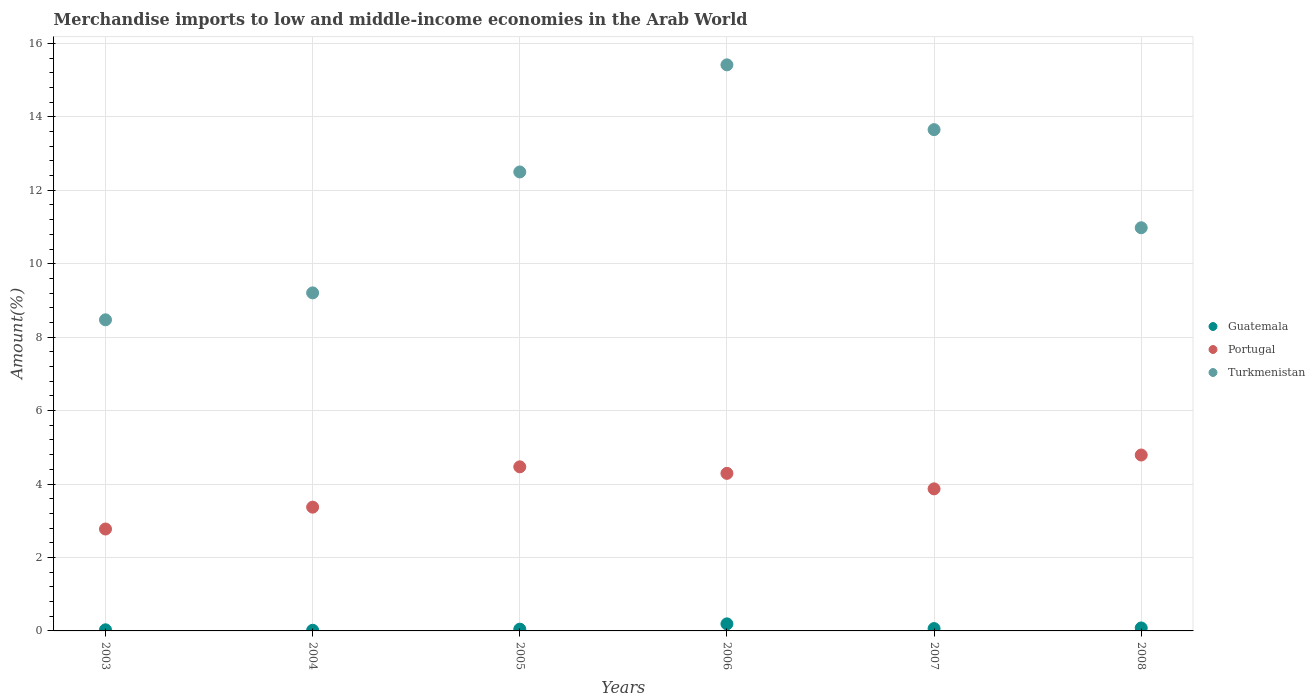Is the number of dotlines equal to the number of legend labels?
Offer a very short reply. Yes. What is the percentage of amount earned from merchandise imports in Portugal in 2007?
Ensure brevity in your answer.  3.87. Across all years, what is the maximum percentage of amount earned from merchandise imports in Guatemala?
Offer a terse response. 0.19. Across all years, what is the minimum percentage of amount earned from merchandise imports in Portugal?
Ensure brevity in your answer.  2.78. In which year was the percentage of amount earned from merchandise imports in Guatemala maximum?
Keep it short and to the point. 2006. What is the total percentage of amount earned from merchandise imports in Portugal in the graph?
Your answer should be very brief. 23.56. What is the difference between the percentage of amount earned from merchandise imports in Guatemala in 2005 and that in 2007?
Provide a succinct answer. -0.02. What is the difference between the percentage of amount earned from merchandise imports in Guatemala in 2003 and the percentage of amount earned from merchandise imports in Turkmenistan in 2005?
Offer a terse response. -12.47. What is the average percentage of amount earned from merchandise imports in Guatemala per year?
Make the answer very short. 0.07. In the year 2007, what is the difference between the percentage of amount earned from merchandise imports in Turkmenistan and percentage of amount earned from merchandise imports in Portugal?
Your answer should be very brief. 9.78. What is the ratio of the percentage of amount earned from merchandise imports in Turkmenistan in 2007 to that in 2008?
Offer a terse response. 1.24. Is the difference between the percentage of amount earned from merchandise imports in Turkmenistan in 2004 and 2007 greater than the difference between the percentage of amount earned from merchandise imports in Portugal in 2004 and 2007?
Your response must be concise. No. What is the difference between the highest and the second highest percentage of amount earned from merchandise imports in Portugal?
Ensure brevity in your answer.  0.32. What is the difference between the highest and the lowest percentage of amount earned from merchandise imports in Guatemala?
Ensure brevity in your answer.  0.17. Is the sum of the percentage of amount earned from merchandise imports in Guatemala in 2003 and 2007 greater than the maximum percentage of amount earned from merchandise imports in Turkmenistan across all years?
Provide a short and direct response. No. Is it the case that in every year, the sum of the percentage of amount earned from merchandise imports in Guatemala and percentage of amount earned from merchandise imports in Turkmenistan  is greater than the percentage of amount earned from merchandise imports in Portugal?
Provide a short and direct response. Yes. How many dotlines are there?
Offer a very short reply. 3. How many years are there in the graph?
Provide a succinct answer. 6. Where does the legend appear in the graph?
Ensure brevity in your answer.  Center right. How are the legend labels stacked?
Provide a short and direct response. Vertical. What is the title of the graph?
Offer a terse response. Merchandise imports to low and middle-income economies in the Arab World. What is the label or title of the X-axis?
Provide a short and direct response. Years. What is the label or title of the Y-axis?
Offer a very short reply. Amount(%). What is the Amount(%) of Guatemala in 2003?
Make the answer very short. 0.03. What is the Amount(%) in Portugal in 2003?
Offer a terse response. 2.78. What is the Amount(%) in Turkmenistan in 2003?
Give a very brief answer. 8.47. What is the Amount(%) of Guatemala in 2004?
Make the answer very short. 0.02. What is the Amount(%) in Portugal in 2004?
Offer a terse response. 3.37. What is the Amount(%) of Turkmenistan in 2004?
Provide a short and direct response. 9.21. What is the Amount(%) in Guatemala in 2005?
Give a very brief answer. 0.05. What is the Amount(%) in Portugal in 2005?
Offer a terse response. 4.47. What is the Amount(%) of Turkmenistan in 2005?
Keep it short and to the point. 12.5. What is the Amount(%) of Guatemala in 2006?
Your answer should be compact. 0.19. What is the Amount(%) of Portugal in 2006?
Provide a succinct answer. 4.29. What is the Amount(%) in Turkmenistan in 2006?
Your answer should be compact. 15.42. What is the Amount(%) of Guatemala in 2007?
Ensure brevity in your answer.  0.06. What is the Amount(%) of Portugal in 2007?
Your response must be concise. 3.87. What is the Amount(%) in Turkmenistan in 2007?
Keep it short and to the point. 13.65. What is the Amount(%) in Guatemala in 2008?
Offer a terse response. 0.08. What is the Amount(%) of Portugal in 2008?
Ensure brevity in your answer.  4.79. What is the Amount(%) in Turkmenistan in 2008?
Offer a very short reply. 10.98. Across all years, what is the maximum Amount(%) in Guatemala?
Your answer should be compact. 0.19. Across all years, what is the maximum Amount(%) of Portugal?
Offer a very short reply. 4.79. Across all years, what is the maximum Amount(%) in Turkmenistan?
Offer a very short reply. 15.42. Across all years, what is the minimum Amount(%) of Guatemala?
Offer a terse response. 0.02. Across all years, what is the minimum Amount(%) of Portugal?
Offer a terse response. 2.78. Across all years, what is the minimum Amount(%) in Turkmenistan?
Offer a very short reply. 8.47. What is the total Amount(%) in Guatemala in the graph?
Ensure brevity in your answer.  0.43. What is the total Amount(%) of Portugal in the graph?
Provide a succinct answer. 23.56. What is the total Amount(%) of Turkmenistan in the graph?
Offer a very short reply. 70.22. What is the difference between the Amount(%) in Guatemala in 2003 and that in 2004?
Make the answer very short. 0.01. What is the difference between the Amount(%) in Portugal in 2003 and that in 2004?
Keep it short and to the point. -0.6. What is the difference between the Amount(%) of Turkmenistan in 2003 and that in 2004?
Offer a terse response. -0.73. What is the difference between the Amount(%) of Guatemala in 2003 and that in 2005?
Offer a terse response. -0.02. What is the difference between the Amount(%) in Portugal in 2003 and that in 2005?
Offer a terse response. -1.69. What is the difference between the Amount(%) in Turkmenistan in 2003 and that in 2005?
Offer a terse response. -4.03. What is the difference between the Amount(%) of Guatemala in 2003 and that in 2006?
Offer a terse response. -0.16. What is the difference between the Amount(%) in Portugal in 2003 and that in 2006?
Provide a succinct answer. -1.52. What is the difference between the Amount(%) of Turkmenistan in 2003 and that in 2006?
Your answer should be very brief. -6.94. What is the difference between the Amount(%) in Guatemala in 2003 and that in 2007?
Keep it short and to the point. -0.03. What is the difference between the Amount(%) of Portugal in 2003 and that in 2007?
Make the answer very short. -1.09. What is the difference between the Amount(%) of Turkmenistan in 2003 and that in 2007?
Ensure brevity in your answer.  -5.18. What is the difference between the Amount(%) in Guatemala in 2003 and that in 2008?
Ensure brevity in your answer.  -0.05. What is the difference between the Amount(%) in Portugal in 2003 and that in 2008?
Offer a terse response. -2.02. What is the difference between the Amount(%) of Turkmenistan in 2003 and that in 2008?
Offer a very short reply. -2.51. What is the difference between the Amount(%) in Guatemala in 2004 and that in 2005?
Offer a terse response. -0.03. What is the difference between the Amount(%) of Portugal in 2004 and that in 2005?
Your response must be concise. -1.1. What is the difference between the Amount(%) of Turkmenistan in 2004 and that in 2005?
Make the answer very short. -3.29. What is the difference between the Amount(%) of Guatemala in 2004 and that in 2006?
Offer a terse response. -0.17. What is the difference between the Amount(%) in Portugal in 2004 and that in 2006?
Your answer should be compact. -0.92. What is the difference between the Amount(%) of Turkmenistan in 2004 and that in 2006?
Your answer should be compact. -6.21. What is the difference between the Amount(%) in Guatemala in 2004 and that in 2007?
Keep it short and to the point. -0.05. What is the difference between the Amount(%) of Portugal in 2004 and that in 2007?
Give a very brief answer. -0.5. What is the difference between the Amount(%) of Turkmenistan in 2004 and that in 2007?
Offer a terse response. -4.45. What is the difference between the Amount(%) in Guatemala in 2004 and that in 2008?
Your answer should be compact. -0.06. What is the difference between the Amount(%) of Portugal in 2004 and that in 2008?
Your answer should be compact. -1.42. What is the difference between the Amount(%) in Turkmenistan in 2004 and that in 2008?
Keep it short and to the point. -1.77. What is the difference between the Amount(%) in Guatemala in 2005 and that in 2006?
Offer a terse response. -0.14. What is the difference between the Amount(%) in Portugal in 2005 and that in 2006?
Keep it short and to the point. 0.18. What is the difference between the Amount(%) of Turkmenistan in 2005 and that in 2006?
Provide a succinct answer. -2.92. What is the difference between the Amount(%) of Guatemala in 2005 and that in 2007?
Ensure brevity in your answer.  -0.02. What is the difference between the Amount(%) in Portugal in 2005 and that in 2007?
Your response must be concise. 0.6. What is the difference between the Amount(%) of Turkmenistan in 2005 and that in 2007?
Offer a very short reply. -1.15. What is the difference between the Amount(%) in Guatemala in 2005 and that in 2008?
Provide a short and direct response. -0.03. What is the difference between the Amount(%) of Portugal in 2005 and that in 2008?
Make the answer very short. -0.32. What is the difference between the Amount(%) of Turkmenistan in 2005 and that in 2008?
Offer a very short reply. 1.52. What is the difference between the Amount(%) in Guatemala in 2006 and that in 2007?
Your response must be concise. 0.13. What is the difference between the Amount(%) in Portugal in 2006 and that in 2007?
Keep it short and to the point. 0.42. What is the difference between the Amount(%) of Turkmenistan in 2006 and that in 2007?
Your answer should be compact. 1.76. What is the difference between the Amount(%) in Guatemala in 2006 and that in 2008?
Keep it short and to the point. 0.11. What is the difference between the Amount(%) in Portugal in 2006 and that in 2008?
Provide a short and direct response. -0.5. What is the difference between the Amount(%) of Turkmenistan in 2006 and that in 2008?
Your response must be concise. 4.44. What is the difference between the Amount(%) of Guatemala in 2007 and that in 2008?
Provide a short and direct response. -0.02. What is the difference between the Amount(%) of Portugal in 2007 and that in 2008?
Make the answer very short. -0.92. What is the difference between the Amount(%) in Turkmenistan in 2007 and that in 2008?
Provide a short and direct response. 2.67. What is the difference between the Amount(%) of Guatemala in 2003 and the Amount(%) of Portugal in 2004?
Your answer should be very brief. -3.34. What is the difference between the Amount(%) of Guatemala in 2003 and the Amount(%) of Turkmenistan in 2004?
Make the answer very short. -9.18. What is the difference between the Amount(%) of Portugal in 2003 and the Amount(%) of Turkmenistan in 2004?
Your response must be concise. -6.43. What is the difference between the Amount(%) in Guatemala in 2003 and the Amount(%) in Portugal in 2005?
Your answer should be very brief. -4.44. What is the difference between the Amount(%) of Guatemala in 2003 and the Amount(%) of Turkmenistan in 2005?
Your response must be concise. -12.47. What is the difference between the Amount(%) of Portugal in 2003 and the Amount(%) of Turkmenistan in 2005?
Your answer should be compact. -9.72. What is the difference between the Amount(%) of Guatemala in 2003 and the Amount(%) of Portugal in 2006?
Keep it short and to the point. -4.26. What is the difference between the Amount(%) in Guatemala in 2003 and the Amount(%) in Turkmenistan in 2006?
Keep it short and to the point. -15.38. What is the difference between the Amount(%) of Portugal in 2003 and the Amount(%) of Turkmenistan in 2006?
Offer a terse response. -12.64. What is the difference between the Amount(%) of Guatemala in 2003 and the Amount(%) of Portugal in 2007?
Make the answer very short. -3.84. What is the difference between the Amount(%) of Guatemala in 2003 and the Amount(%) of Turkmenistan in 2007?
Give a very brief answer. -13.62. What is the difference between the Amount(%) in Portugal in 2003 and the Amount(%) in Turkmenistan in 2007?
Give a very brief answer. -10.88. What is the difference between the Amount(%) in Guatemala in 2003 and the Amount(%) in Portugal in 2008?
Provide a succinct answer. -4.76. What is the difference between the Amount(%) of Guatemala in 2003 and the Amount(%) of Turkmenistan in 2008?
Offer a very short reply. -10.95. What is the difference between the Amount(%) of Portugal in 2003 and the Amount(%) of Turkmenistan in 2008?
Your response must be concise. -8.2. What is the difference between the Amount(%) of Guatemala in 2004 and the Amount(%) of Portugal in 2005?
Ensure brevity in your answer.  -4.45. What is the difference between the Amount(%) of Guatemala in 2004 and the Amount(%) of Turkmenistan in 2005?
Offer a very short reply. -12.48. What is the difference between the Amount(%) in Portugal in 2004 and the Amount(%) in Turkmenistan in 2005?
Ensure brevity in your answer.  -9.13. What is the difference between the Amount(%) in Guatemala in 2004 and the Amount(%) in Portugal in 2006?
Your answer should be compact. -4.27. What is the difference between the Amount(%) of Guatemala in 2004 and the Amount(%) of Turkmenistan in 2006?
Your answer should be very brief. -15.4. What is the difference between the Amount(%) of Portugal in 2004 and the Amount(%) of Turkmenistan in 2006?
Give a very brief answer. -12.04. What is the difference between the Amount(%) of Guatemala in 2004 and the Amount(%) of Portugal in 2007?
Ensure brevity in your answer.  -3.85. What is the difference between the Amount(%) in Guatemala in 2004 and the Amount(%) in Turkmenistan in 2007?
Provide a short and direct response. -13.63. What is the difference between the Amount(%) of Portugal in 2004 and the Amount(%) of Turkmenistan in 2007?
Give a very brief answer. -10.28. What is the difference between the Amount(%) in Guatemala in 2004 and the Amount(%) in Portugal in 2008?
Your answer should be compact. -4.77. What is the difference between the Amount(%) of Guatemala in 2004 and the Amount(%) of Turkmenistan in 2008?
Provide a succinct answer. -10.96. What is the difference between the Amount(%) of Portugal in 2004 and the Amount(%) of Turkmenistan in 2008?
Keep it short and to the point. -7.61. What is the difference between the Amount(%) of Guatemala in 2005 and the Amount(%) of Portugal in 2006?
Keep it short and to the point. -4.24. What is the difference between the Amount(%) of Guatemala in 2005 and the Amount(%) of Turkmenistan in 2006?
Your answer should be compact. -15.37. What is the difference between the Amount(%) of Portugal in 2005 and the Amount(%) of Turkmenistan in 2006?
Your answer should be very brief. -10.95. What is the difference between the Amount(%) of Guatemala in 2005 and the Amount(%) of Portugal in 2007?
Offer a terse response. -3.82. What is the difference between the Amount(%) in Guatemala in 2005 and the Amount(%) in Turkmenistan in 2007?
Provide a succinct answer. -13.6. What is the difference between the Amount(%) of Portugal in 2005 and the Amount(%) of Turkmenistan in 2007?
Offer a terse response. -9.18. What is the difference between the Amount(%) of Guatemala in 2005 and the Amount(%) of Portugal in 2008?
Your response must be concise. -4.74. What is the difference between the Amount(%) in Guatemala in 2005 and the Amount(%) in Turkmenistan in 2008?
Provide a short and direct response. -10.93. What is the difference between the Amount(%) in Portugal in 2005 and the Amount(%) in Turkmenistan in 2008?
Your answer should be compact. -6.51. What is the difference between the Amount(%) of Guatemala in 2006 and the Amount(%) of Portugal in 2007?
Your answer should be very brief. -3.68. What is the difference between the Amount(%) of Guatemala in 2006 and the Amount(%) of Turkmenistan in 2007?
Ensure brevity in your answer.  -13.46. What is the difference between the Amount(%) in Portugal in 2006 and the Amount(%) in Turkmenistan in 2007?
Provide a succinct answer. -9.36. What is the difference between the Amount(%) of Guatemala in 2006 and the Amount(%) of Portugal in 2008?
Your answer should be compact. -4.6. What is the difference between the Amount(%) of Guatemala in 2006 and the Amount(%) of Turkmenistan in 2008?
Your answer should be compact. -10.79. What is the difference between the Amount(%) of Portugal in 2006 and the Amount(%) of Turkmenistan in 2008?
Offer a very short reply. -6.69. What is the difference between the Amount(%) of Guatemala in 2007 and the Amount(%) of Portugal in 2008?
Ensure brevity in your answer.  -4.73. What is the difference between the Amount(%) in Guatemala in 2007 and the Amount(%) in Turkmenistan in 2008?
Provide a short and direct response. -10.92. What is the difference between the Amount(%) in Portugal in 2007 and the Amount(%) in Turkmenistan in 2008?
Offer a terse response. -7.11. What is the average Amount(%) in Guatemala per year?
Give a very brief answer. 0.07. What is the average Amount(%) in Portugal per year?
Your response must be concise. 3.93. What is the average Amount(%) in Turkmenistan per year?
Ensure brevity in your answer.  11.7. In the year 2003, what is the difference between the Amount(%) of Guatemala and Amount(%) of Portugal?
Your answer should be compact. -2.74. In the year 2003, what is the difference between the Amount(%) in Guatemala and Amount(%) in Turkmenistan?
Make the answer very short. -8.44. In the year 2003, what is the difference between the Amount(%) of Portugal and Amount(%) of Turkmenistan?
Offer a very short reply. -5.7. In the year 2004, what is the difference between the Amount(%) of Guatemala and Amount(%) of Portugal?
Your response must be concise. -3.35. In the year 2004, what is the difference between the Amount(%) of Guatemala and Amount(%) of Turkmenistan?
Your answer should be very brief. -9.19. In the year 2004, what is the difference between the Amount(%) of Portugal and Amount(%) of Turkmenistan?
Ensure brevity in your answer.  -5.84. In the year 2005, what is the difference between the Amount(%) in Guatemala and Amount(%) in Portugal?
Provide a succinct answer. -4.42. In the year 2005, what is the difference between the Amount(%) of Guatemala and Amount(%) of Turkmenistan?
Your answer should be compact. -12.45. In the year 2005, what is the difference between the Amount(%) in Portugal and Amount(%) in Turkmenistan?
Keep it short and to the point. -8.03. In the year 2006, what is the difference between the Amount(%) of Guatemala and Amount(%) of Portugal?
Offer a very short reply. -4.1. In the year 2006, what is the difference between the Amount(%) of Guatemala and Amount(%) of Turkmenistan?
Keep it short and to the point. -15.22. In the year 2006, what is the difference between the Amount(%) of Portugal and Amount(%) of Turkmenistan?
Your answer should be compact. -11.12. In the year 2007, what is the difference between the Amount(%) in Guatemala and Amount(%) in Portugal?
Your answer should be compact. -3.81. In the year 2007, what is the difference between the Amount(%) of Guatemala and Amount(%) of Turkmenistan?
Your response must be concise. -13.59. In the year 2007, what is the difference between the Amount(%) in Portugal and Amount(%) in Turkmenistan?
Keep it short and to the point. -9.78. In the year 2008, what is the difference between the Amount(%) in Guatemala and Amount(%) in Portugal?
Offer a terse response. -4.71. In the year 2008, what is the difference between the Amount(%) of Guatemala and Amount(%) of Turkmenistan?
Provide a short and direct response. -10.9. In the year 2008, what is the difference between the Amount(%) of Portugal and Amount(%) of Turkmenistan?
Ensure brevity in your answer.  -6.19. What is the ratio of the Amount(%) in Guatemala in 2003 to that in 2004?
Make the answer very short. 1.71. What is the ratio of the Amount(%) in Portugal in 2003 to that in 2004?
Keep it short and to the point. 0.82. What is the ratio of the Amount(%) of Turkmenistan in 2003 to that in 2004?
Make the answer very short. 0.92. What is the ratio of the Amount(%) in Guatemala in 2003 to that in 2005?
Your answer should be very brief. 0.64. What is the ratio of the Amount(%) in Portugal in 2003 to that in 2005?
Ensure brevity in your answer.  0.62. What is the ratio of the Amount(%) of Turkmenistan in 2003 to that in 2005?
Your response must be concise. 0.68. What is the ratio of the Amount(%) in Guatemala in 2003 to that in 2006?
Offer a very short reply. 0.16. What is the ratio of the Amount(%) of Portugal in 2003 to that in 2006?
Give a very brief answer. 0.65. What is the ratio of the Amount(%) in Turkmenistan in 2003 to that in 2006?
Offer a very short reply. 0.55. What is the ratio of the Amount(%) in Guatemala in 2003 to that in 2007?
Offer a terse response. 0.48. What is the ratio of the Amount(%) in Portugal in 2003 to that in 2007?
Your answer should be very brief. 0.72. What is the ratio of the Amount(%) of Turkmenistan in 2003 to that in 2007?
Provide a short and direct response. 0.62. What is the ratio of the Amount(%) of Guatemala in 2003 to that in 2008?
Give a very brief answer. 0.38. What is the ratio of the Amount(%) in Portugal in 2003 to that in 2008?
Provide a short and direct response. 0.58. What is the ratio of the Amount(%) of Turkmenistan in 2003 to that in 2008?
Offer a very short reply. 0.77. What is the ratio of the Amount(%) of Guatemala in 2004 to that in 2005?
Make the answer very short. 0.37. What is the ratio of the Amount(%) of Portugal in 2004 to that in 2005?
Offer a terse response. 0.75. What is the ratio of the Amount(%) of Turkmenistan in 2004 to that in 2005?
Your answer should be compact. 0.74. What is the ratio of the Amount(%) of Guatemala in 2004 to that in 2006?
Offer a very short reply. 0.09. What is the ratio of the Amount(%) of Portugal in 2004 to that in 2006?
Offer a very short reply. 0.79. What is the ratio of the Amount(%) in Turkmenistan in 2004 to that in 2006?
Offer a very short reply. 0.6. What is the ratio of the Amount(%) of Guatemala in 2004 to that in 2007?
Keep it short and to the point. 0.28. What is the ratio of the Amount(%) of Portugal in 2004 to that in 2007?
Ensure brevity in your answer.  0.87. What is the ratio of the Amount(%) of Turkmenistan in 2004 to that in 2007?
Provide a succinct answer. 0.67. What is the ratio of the Amount(%) of Guatemala in 2004 to that in 2008?
Keep it short and to the point. 0.22. What is the ratio of the Amount(%) of Portugal in 2004 to that in 2008?
Give a very brief answer. 0.7. What is the ratio of the Amount(%) in Turkmenistan in 2004 to that in 2008?
Offer a terse response. 0.84. What is the ratio of the Amount(%) in Guatemala in 2005 to that in 2006?
Offer a terse response. 0.25. What is the ratio of the Amount(%) in Portugal in 2005 to that in 2006?
Keep it short and to the point. 1.04. What is the ratio of the Amount(%) in Turkmenistan in 2005 to that in 2006?
Ensure brevity in your answer.  0.81. What is the ratio of the Amount(%) in Guatemala in 2005 to that in 2007?
Offer a very short reply. 0.75. What is the ratio of the Amount(%) of Portugal in 2005 to that in 2007?
Your response must be concise. 1.16. What is the ratio of the Amount(%) in Turkmenistan in 2005 to that in 2007?
Your answer should be compact. 0.92. What is the ratio of the Amount(%) of Guatemala in 2005 to that in 2008?
Offer a very short reply. 0.59. What is the ratio of the Amount(%) in Portugal in 2005 to that in 2008?
Your answer should be very brief. 0.93. What is the ratio of the Amount(%) in Turkmenistan in 2005 to that in 2008?
Keep it short and to the point. 1.14. What is the ratio of the Amount(%) in Guatemala in 2006 to that in 2007?
Ensure brevity in your answer.  3.01. What is the ratio of the Amount(%) of Portugal in 2006 to that in 2007?
Keep it short and to the point. 1.11. What is the ratio of the Amount(%) of Turkmenistan in 2006 to that in 2007?
Provide a short and direct response. 1.13. What is the ratio of the Amount(%) in Guatemala in 2006 to that in 2008?
Ensure brevity in your answer.  2.38. What is the ratio of the Amount(%) of Portugal in 2006 to that in 2008?
Your answer should be compact. 0.9. What is the ratio of the Amount(%) in Turkmenistan in 2006 to that in 2008?
Keep it short and to the point. 1.4. What is the ratio of the Amount(%) in Guatemala in 2007 to that in 2008?
Your response must be concise. 0.79. What is the ratio of the Amount(%) in Portugal in 2007 to that in 2008?
Give a very brief answer. 0.81. What is the ratio of the Amount(%) in Turkmenistan in 2007 to that in 2008?
Your answer should be compact. 1.24. What is the difference between the highest and the second highest Amount(%) of Guatemala?
Ensure brevity in your answer.  0.11. What is the difference between the highest and the second highest Amount(%) of Portugal?
Keep it short and to the point. 0.32. What is the difference between the highest and the second highest Amount(%) in Turkmenistan?
Offer a terse response. 1.76. What is the difference between the highest and the lowest Amount(%) of Guatemala?
Make the answer very short. 0.17. What is the difference between the highest and the lowest Amount(%) in Portugal?
Provide a short and direct response. 2.02. What is the difference between the highest and the lowest Amount(%) in Turkmenistan?
Provide a short and direct response. 6.94. 